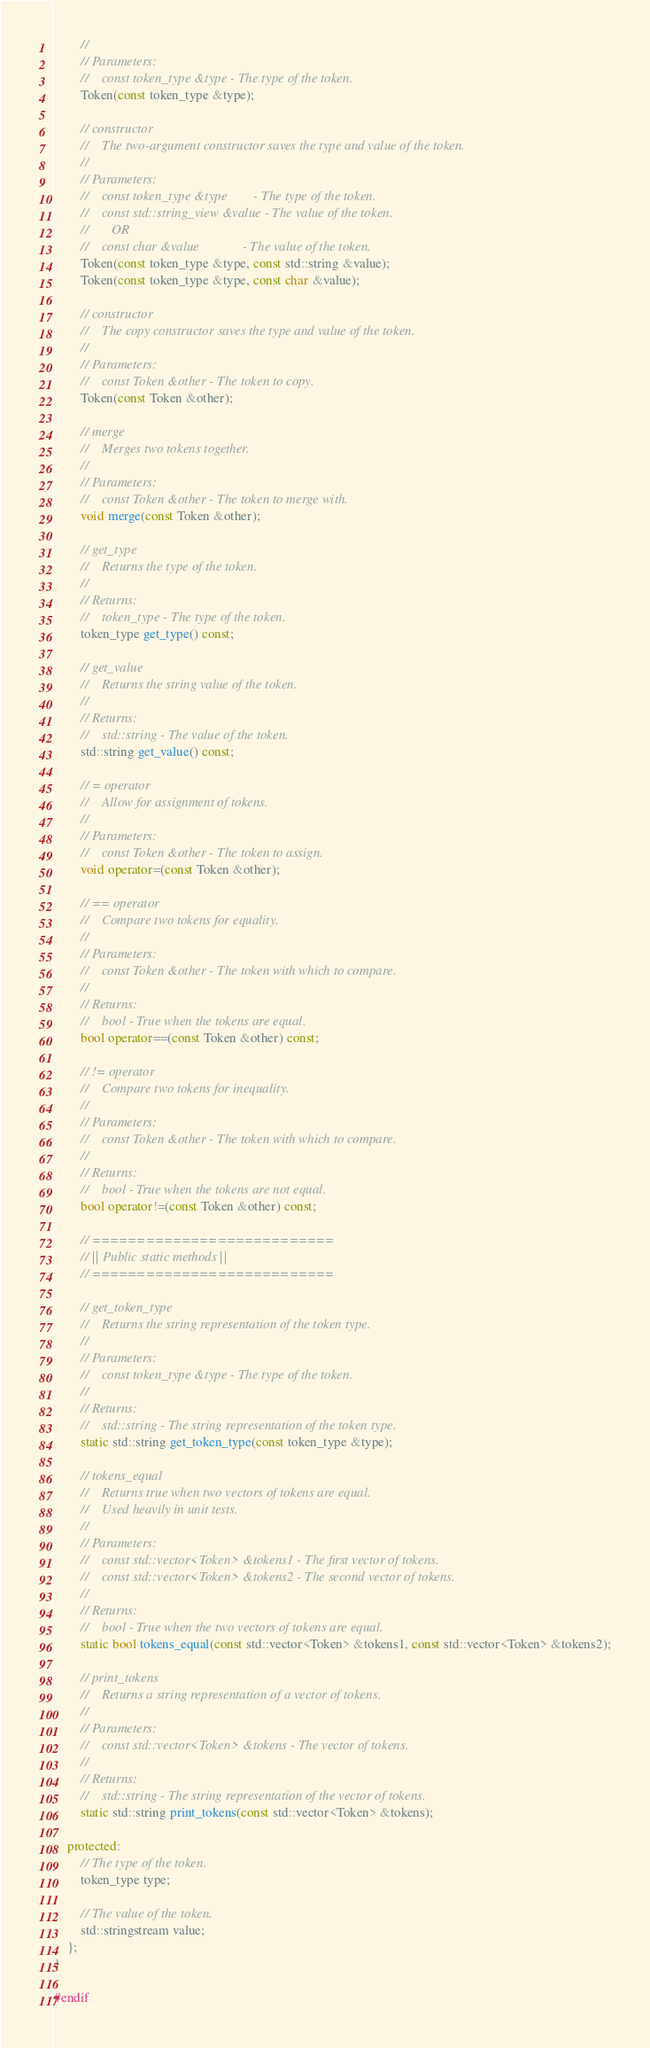<code> <loc_0><loc_0><loc_500><loc_500><_C++_>        //
        // Parameters:
        //    const token_type &type - The type of the token.
        Token(const token_type &type);

        // constructor
        //    The two-argument constructor saves the type and value of the token.
        //
        // Parameters:
        //    const token_type &type        - The type of the token.
        //    const std::string_view &value - The value of the token.
        //       OR
        //    const char &value             - The value of the token.
        Token(const token_type &type, const std::string &value);
        Token(const token_type &type, const char &value);

        // constructor
        //    The copy constructor saves the type and value of the token.
        //
        // Parameters:
        //    const Token &other - The token to copy.
        Token(const Token &other);

        // merge
        //    Merges two tokens together.
        //
        // Parameters:
        //    const Token &other - The token to merge with.
        void merge(const Token &other);

        // get_type
        //    Returns the type of the token.
        //
        // Returns:
        //    token_type - The type of the token.
        token_type get_type() const;

        // get_value
        //    Returns the string value of the token.
        //
        // Returns:
        //    std::string - The value of the token.
        std::string get_value() const;

        // = operator
        //    Allow for assignment of tokens.
        //
        // Parameters:
        //    const Token &other - The token to assign.
        void operator=(const Token &other);

        // == operator
        //    Compare two tokens for equality.
        //
        // Parameters:
        //    const Token &other - The token with which to compare.
        //
        // Returns:
        //    bool - True when the tokens are equal.
        bool operator==(const Token &other) const;

        // != operator
        //    Compare two tokens for inequality.
        //
        // Parameters:
        //    const Token &other - The token with which to compare.
        //
        // Returns:
        //    bool - True when the tokens are not equal.
        bool operator!=(const Token &other) const;

        // ===========================
        // || Public static methods ||
        // ===========================

        // get_token_type
        //    Returns the string representation of the token type.
        //
        // Parameters:
        //    const token_type &type - The type of the token.
        //
        // Returns:
        //    std::string - The string representation of the token type.
        static std::string get_token_type(const token_type &type);

        // tokens_equal
        //    Returns true when two vectors of tokens are equal.
        //    Used heavily in unit tests.
        //
        // Parameters:
        //    const std::vector<Token> &tokens1 - The first vector of tokens.
        //    const std::vector<Token> &tokens2 - The second vector of tokens.
        //
        // Returns:
        //    bool - True when the two vectors of tokens are equal.
        static bool tokens_equal(const std::vector<Token> &tokens1, const std::vector<Token> &tokens2);

        // print_tokens
        //    Returns a string representation of a vector of tokens.
        //
        // Parameters:
        //    const std::vector<Token> &tokens - The vector of tokens.
        //
        // Returns:
        //    std::string - The string representation of the vector of tokens.
        static std::string print_tokens(const std::vector<Token> &tokens);

    protected:
        // The type of the token.
        token_type type;

        // The value of the token.
        std::stringstream value;
    };
}

#endif</code> 